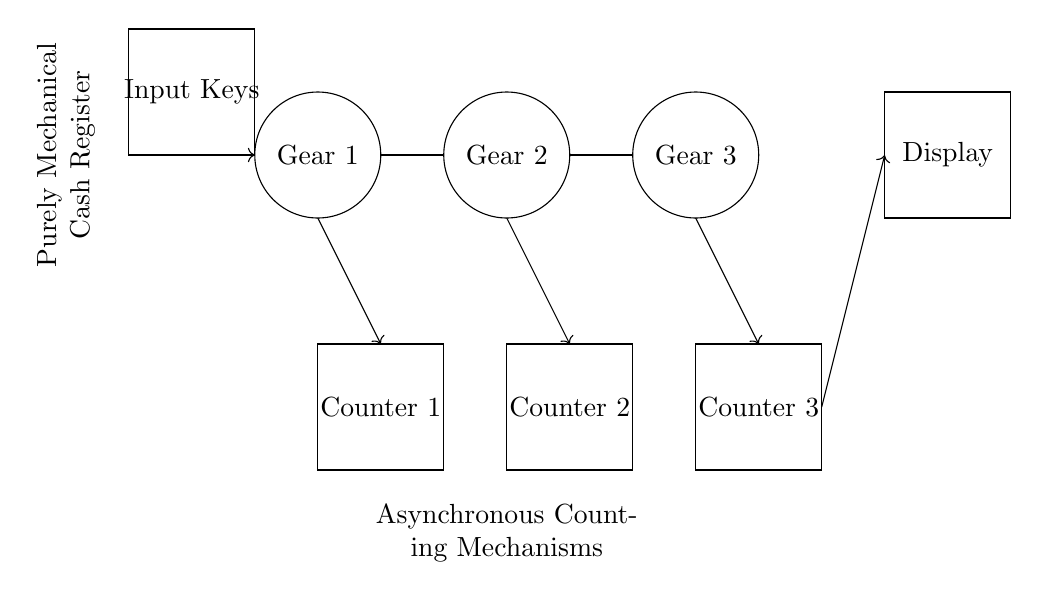What is the function of Counter 1? Counter 1 acts as an asynchronous counting mechanism that tracks the input from the keys, thereby allowing for the accurate tally of transactions.
Answer: Asynchronous counting mechanism What connects Gear 1 to Counter 1? A thick connecting rod directly links Gear 1 to Counter 1, indicating that the motion from Gear 1 is utilized for the counting mechanism in Counter 1.
Answer: Thick connecting rod How many gears are present in the circuit diagram? The diagram depicts three gears; Gear 1, Gear 2, and Gear 3, which are interconnected for the mechanical counting process.
Answer: Three Which component displays the count? The Display component is responsible for showing the results of the counting mechanisms, receiving input from the respective counters through arrows.
Answer: Display What type of counting does the register utilize? The cash register employs asynchronous counting, as denoted in the circuit, emphasizing that the counting process occurs independently across the mechanisms.
Answer: Asynchronous counting What is the shape of the Input Keys component? The Input Keys component is represented by a rectangle shape, which signifies the user interface for inputting values into the cash register.
Answer: Rectangle Where does the counting mechanism take input from? The counting mechanism takes input directly from the Input Keys, indicated by the directed arrows leading from the keys to Gear 1 and subsequently to the counters.
Answer: Input Keys 